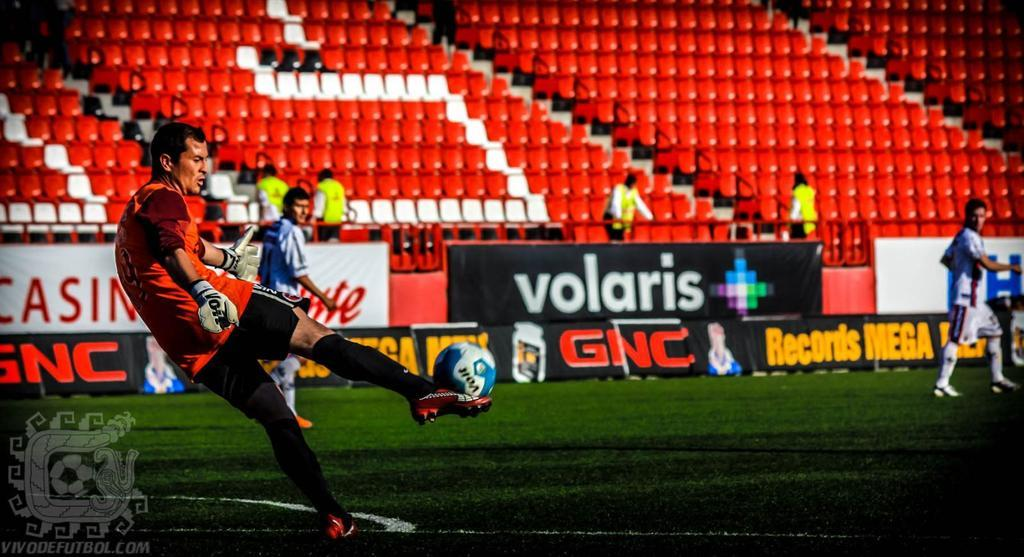Provide a one-sentence caption for the provided image. A soccer game that is sponsored by GNC. 